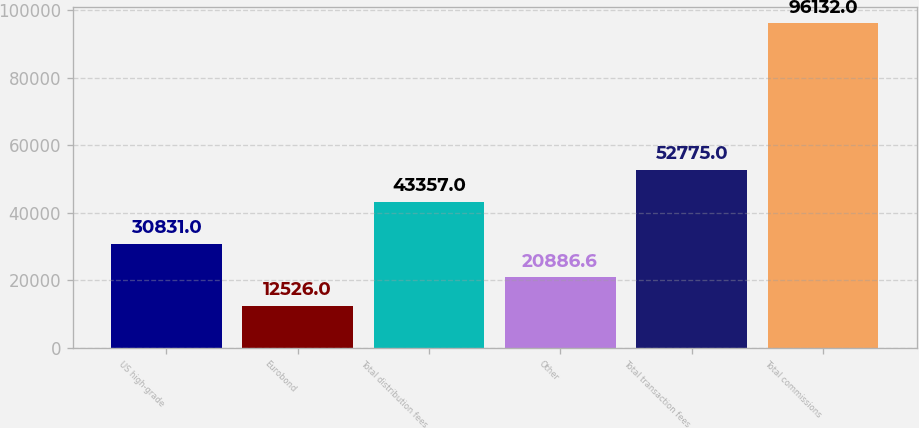<chart> <loc_0><loc_0><loc_500><loc_500><bar_chart><fcel>US high-grade<fcel>Eurobond<fcel>Total distribution fees<fcel>Other<fcel>Total transaction fees<fcel>Total commissions<nl><fcel>30831<fcel>12526<fcel>43357<fcel>20886.6<fcel>52775<fcel>96132<nl></chart> 